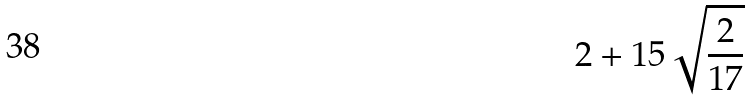Convert formula to latex. <formula><loc_0><loc_0><loc_500><loc_500>2 + 1 5 \sqrt { \frac { 2 } { 1 7 } }</formula> 